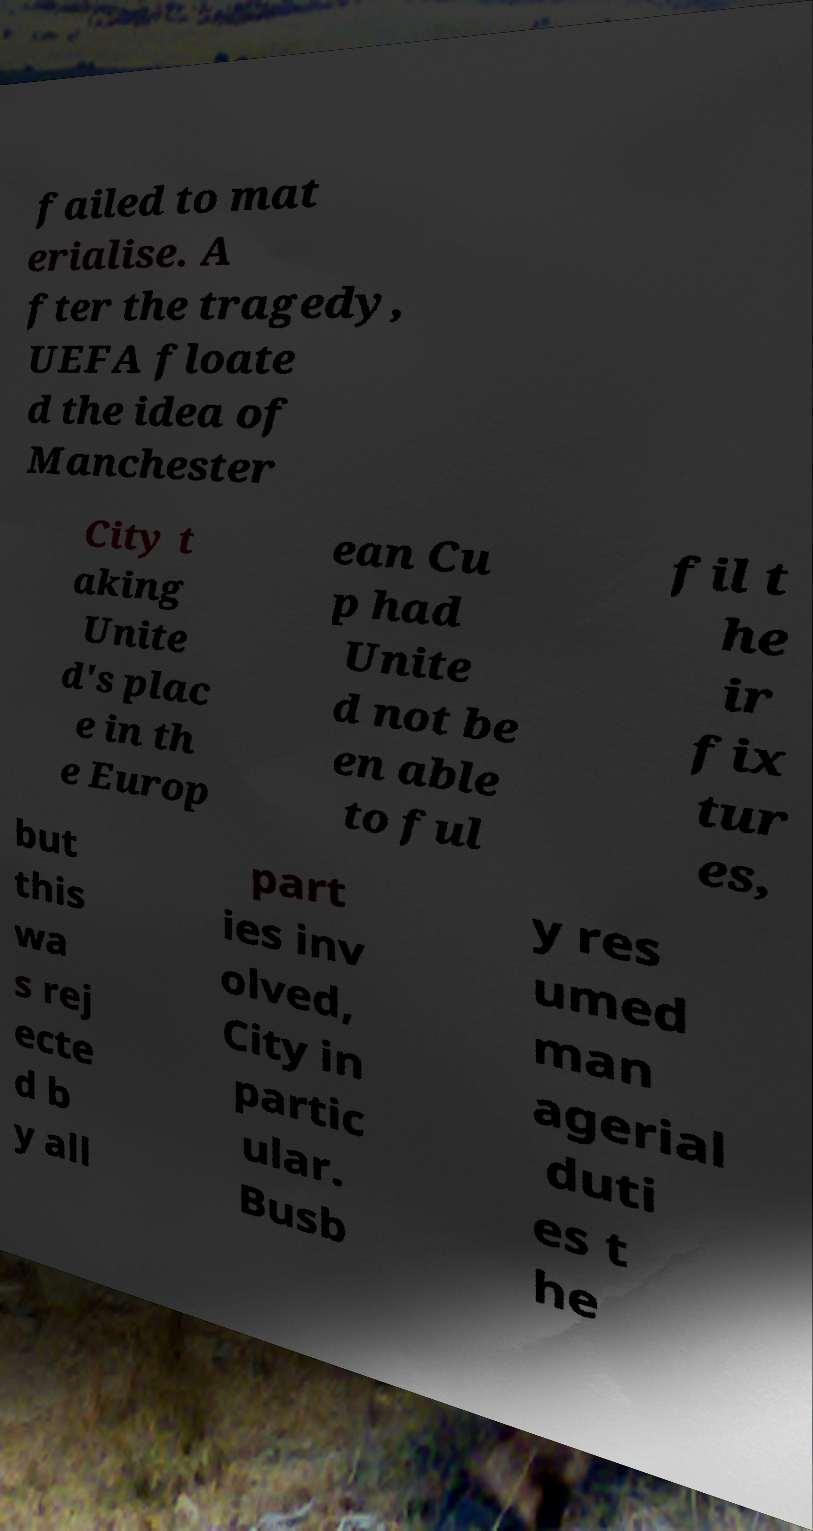I need the written content from this picture converted into text. Can you do that? failed to mat erialise. A fter the tragedy, UEFA floate d the idea of Manchester City t aking Unite d's plac e in th e Europ ean Cu p had Unite d not be en able to ful fil t he ir fix tur es, but this wa s rej ecte d b y all part ies inv olved, City in partic ular. Busb y res umed man agerial duti es t he 